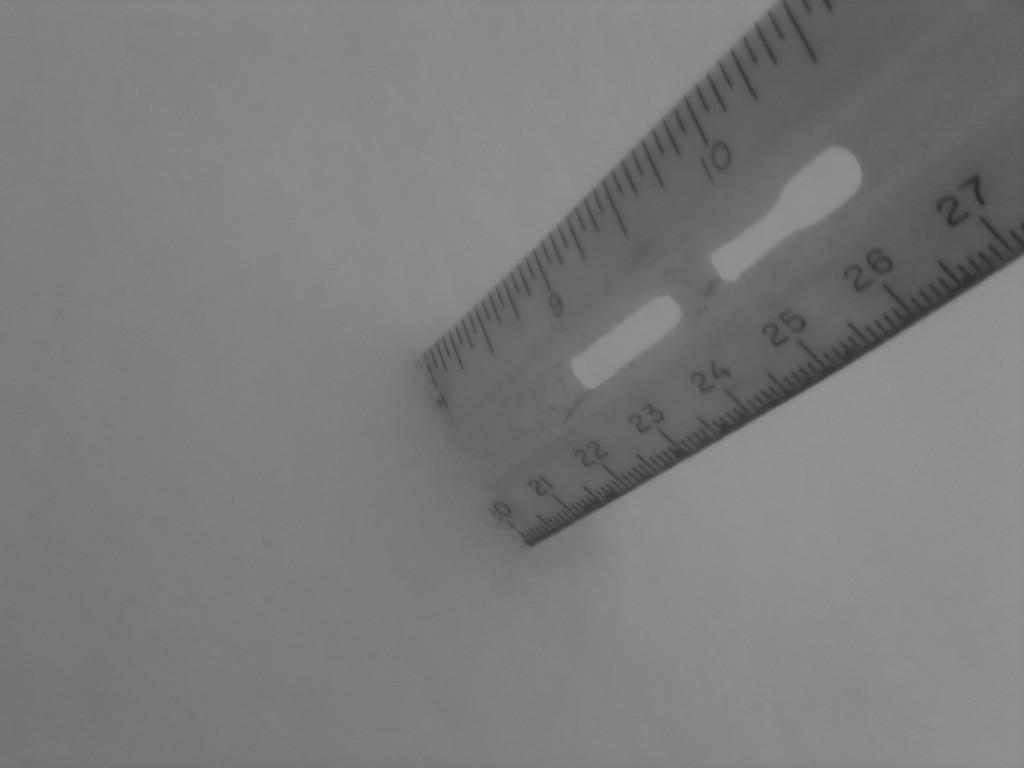<image>
Create a compact narrative representing the image presented. A ruler is held upright with the 27 centimeters mark close to the top. 